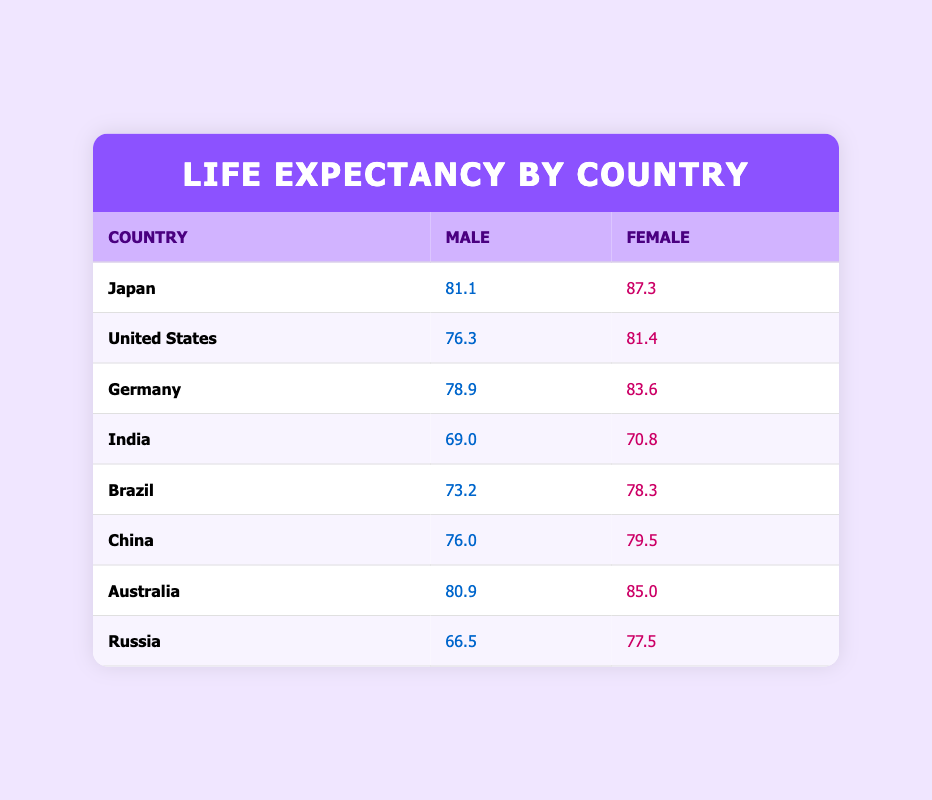What is the life expectancy for males in Japan? In the table, under the row for Japan, the value for male life expectancy is directly provided, which is 81.1 years.
Answer: 81.1 What is the life expectancy for females in Australia? Looking at the row for Australia, the male life expectancy is listed as 80.9 and the female life expectancy is listed as 85.0 years. Thus, the value for females is directly found.
Answer: 85.0 Which country has the highest life expectancy for females? By examining the female life expectancy values in the table, Japan has the highest value at 87.3 years, more than all other countries listed.
Answer: Japan Is the female life expectancy in India greater than that of males? In the row for India, the male life expectancy is 69.0 years, while the female life expectancy is 70.8 years. Since 70.8 is greater than 69.0, the answer is yes.
Answer: Yes What is the difference in life expectancy between males and females in Germany? For Germany, the life expectancy for males is 78.9 years and for females is 83.6 years. The difference can be calculated as 83.6 - 78.9, which is 4.7 years.
Answer: 4.7 Which country has the largest gap between male and female life expectancy? We can compare the differences in life expectancy for each country. For example, Japan has a gap of 6.2 years (87.3 - 81.1), and Russia has a gap of 11 years (77.5 - 66.5). Upon comparing all, Russia shows the largest gap.
Answer: Russia Is it true that life expectancy for males is higher in Australia than in Brazil? Referring to the life expectancy values, Australia has a male life expectancy of 80.9 while Brazil has 73.2. Since 80.9 is greater than 73.2, the statement is true.
Answer: True What is the average life expectancy for males across all the countries in the table? To calculate the average, sum the male life expectancies: 81.1 + 76.3 + 78.9 + 69.0 + 73.2 + 76.0 + 80.9 + 66.5 = 502.9. Then, divide by the number of countries, which is 8. So, 502.9 / 8 = 62.86.
Answer: 62.86 What can we infer about the relative life expectancy between genders in China? The male life expectancy in China is 76.0 years, and the female life expectancy is 79.5 years. Female life expectancy being higher indicates a trend that reflects better longevity for females in this country.
Answer: Females live longer than males 